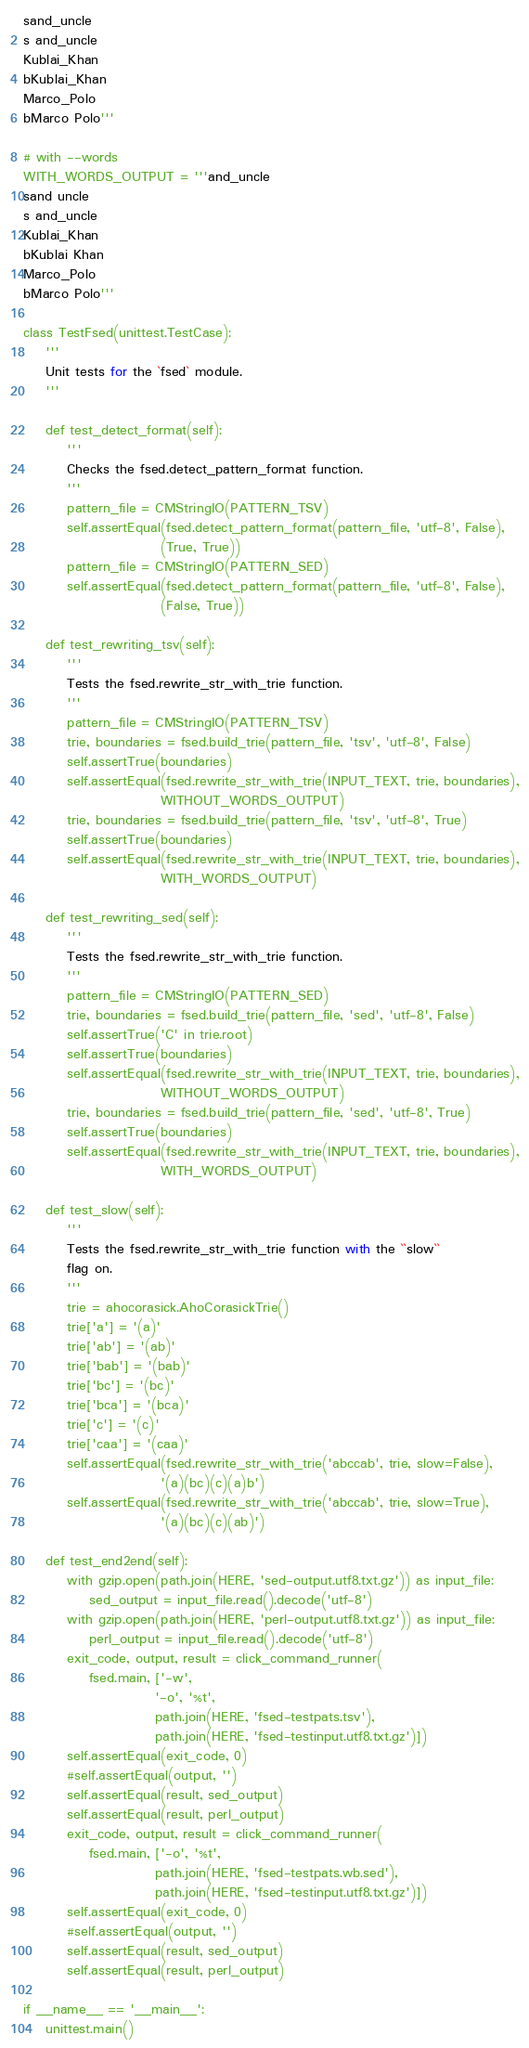<code> <loc_0><loc_0><loc_500><loc_500><_Python_>sand_uncle
s and_uncle
Kublai_Khan
bKublai_Khan
Marco_Polo
bMarco Polo'''

# with --words
WITH_WORDS_OUTPUT = '''and_uncle
sand uncle
s and_uncle
Kublai_Khan
bKublai Khan
Marco_Polo
bMarco Polo'''

class TestFsed(unittest.TestCase):
    '''
    Unit tests for the `fsed` module.
    '''

    def test_detect_format(self):
        '''
        Checks the fsed.detect_pattern_format function.
        '''
        pattern_file = CMStringIO(PATTERN_TSV)
        self.assertEqual(fsed.detect_pattern_format(pattern_file, 'utf-8', False),
                         (True, True))
        pattern_file = CMStringIO(PATTERN_SED)
        self.assertEqual(fsed.detect_pattern_format(pattern_file, 'utf-8', False),
                         (False, True))

    def test_rewriting_tsv(self):
        '''
        Tests the fsed.rewrite_str_with_trie function.
        '''
        pattern_file = CMStringIO(PATTERN_TSV)
        trie, boundaries = fsed.build_trie(pattern_file, 'tsv', 'utf-8', False)
        self.assertTrue(boundaries)
        self.assertEqual(fsed.rewrite_str_with_trie(INPUT_TEXT, trie, boundaries),
                         WITHOUT_WORDS_OUTPUT)
        trie, boundaries = fsed.build_trie(pattern_file, 'tsv', 'utf-8', True)
        self.assertTrue(boundaries)
        self.assertEqual(fsed.rewrite_str_with_trie(INPUT_TEXT, trie, boundaries),
                         WITH_WORDS_OUTPUT)

    def test_rewriting_sed(self):
        '''
        Tests the fsed.rewrite_str_with_trie function.
        '''
        pattern_file = CMStringIO(PATTERN_SED)
        trie, boundaries = fsed.build_trie(pattern_file, 'sed', 'utf-8', False)
        self.assertTrue('C' in trie.root)
        self.assertTrue(boundaries)
        self.assertEqual(fsed.rewrite_str_with_trie(INPUT_TEXT, trie, boundaries),
                         WITHOUT_WORDS_OUTPUT)
        trie, boundaries = fsed.build_trie(pattern_file, 'sed', 'utf-8', True)
        self.assertTrue(boundaries)
        self.assertEqual(fsed.rewrite_str_with_trie(INPUT_TEXT, trie, boundaries),
                         WITH_WORDS_OUTPUT)

    def test_slow(self):
        '''
        Tests the fsed.rewrite_str_with_trie function with the ``slow``
        flag on.
        '''
        trie = ahocorasick.AhoCorasickTrie()
        trie['a'] = '(a)'
        trie['ab'] = '(ab)'
        trie['bab'] = '(bab)'
        trie['bc'] = '(bc)'
        trie['bca'] = '(bca)'
        trie['c'] = '(c)'
        trie['caa'] = '(caa)'
        self.assertEqual(fsed.rewrite_str_with_trie('abccab', trie, slow=False),
                         '(a)(bc)(c)(a)b')
        self.assertEqual(fsed.rewrite_str_with_trie('abccab', trie, slow=True),
                         '(a)(bc)(c)(ab)')

    def test_end2end(self):
        with gzip.open(path.join(HERE, 'sed-output.utf8.txt.gz')) as input_file:
            sed_output = input_file.read().decode('utf-8')
        with gzip.open(path.join(HERE, 'perl-output.utf8.txt.gz')) as input_file:
            perl_output = input_file.read().decode('utf-8')
        exit_code, output, result = click_command_runner(
            fsed.main, ['-w',
                        '-o', '%t',
                        path.join(HERE, 'fsed-testpats.tsv'),
                        path.join(HERE, 'fsed-testinput.utf8.txt.gz')])
        self.assertEqual(exit_code, 0)
        #self.assertEqual(output, '')
        self.assertEqual(result, sed_output)
        self.assertEqual(result, perl_output)
        exit_code, output, result = click_command_runner(
            fsed.main, ['-o', '%t',
                        path.join(HERE, 'fsed-testpats.wb.sed'),
                        path.join(HERE, 'fsed-testinput.utf8.txt.gz')])
        self.assertEqual(exit_code, 0)
        #self.assertEqual(output, '')
        self.assertEqual(result, sed_output)
        self.assertEqual(result, perl_output)

if __name__ == '__main__':
    unittest.main()
</code> 